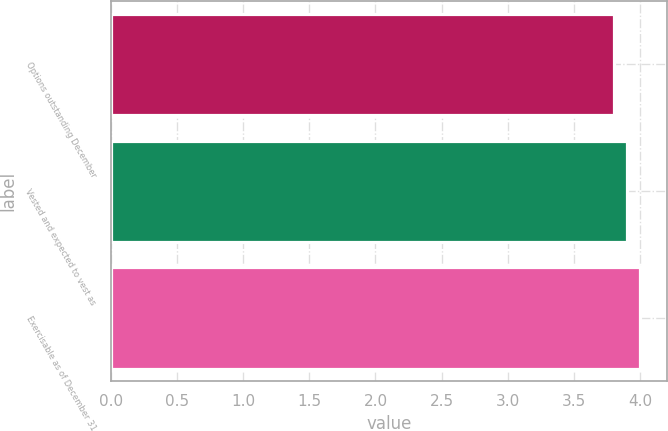Convert chart to OTSL. <chart><loc_0><loc_0><loc_500><loc_500><bar_chart><fcel>Options outstanding December<fcel>Vested and expected to vest as<fcel>Exercisable as of December 31<nl><fcel>3.8<fcel>3.9<fcel>4<nl></chart> 